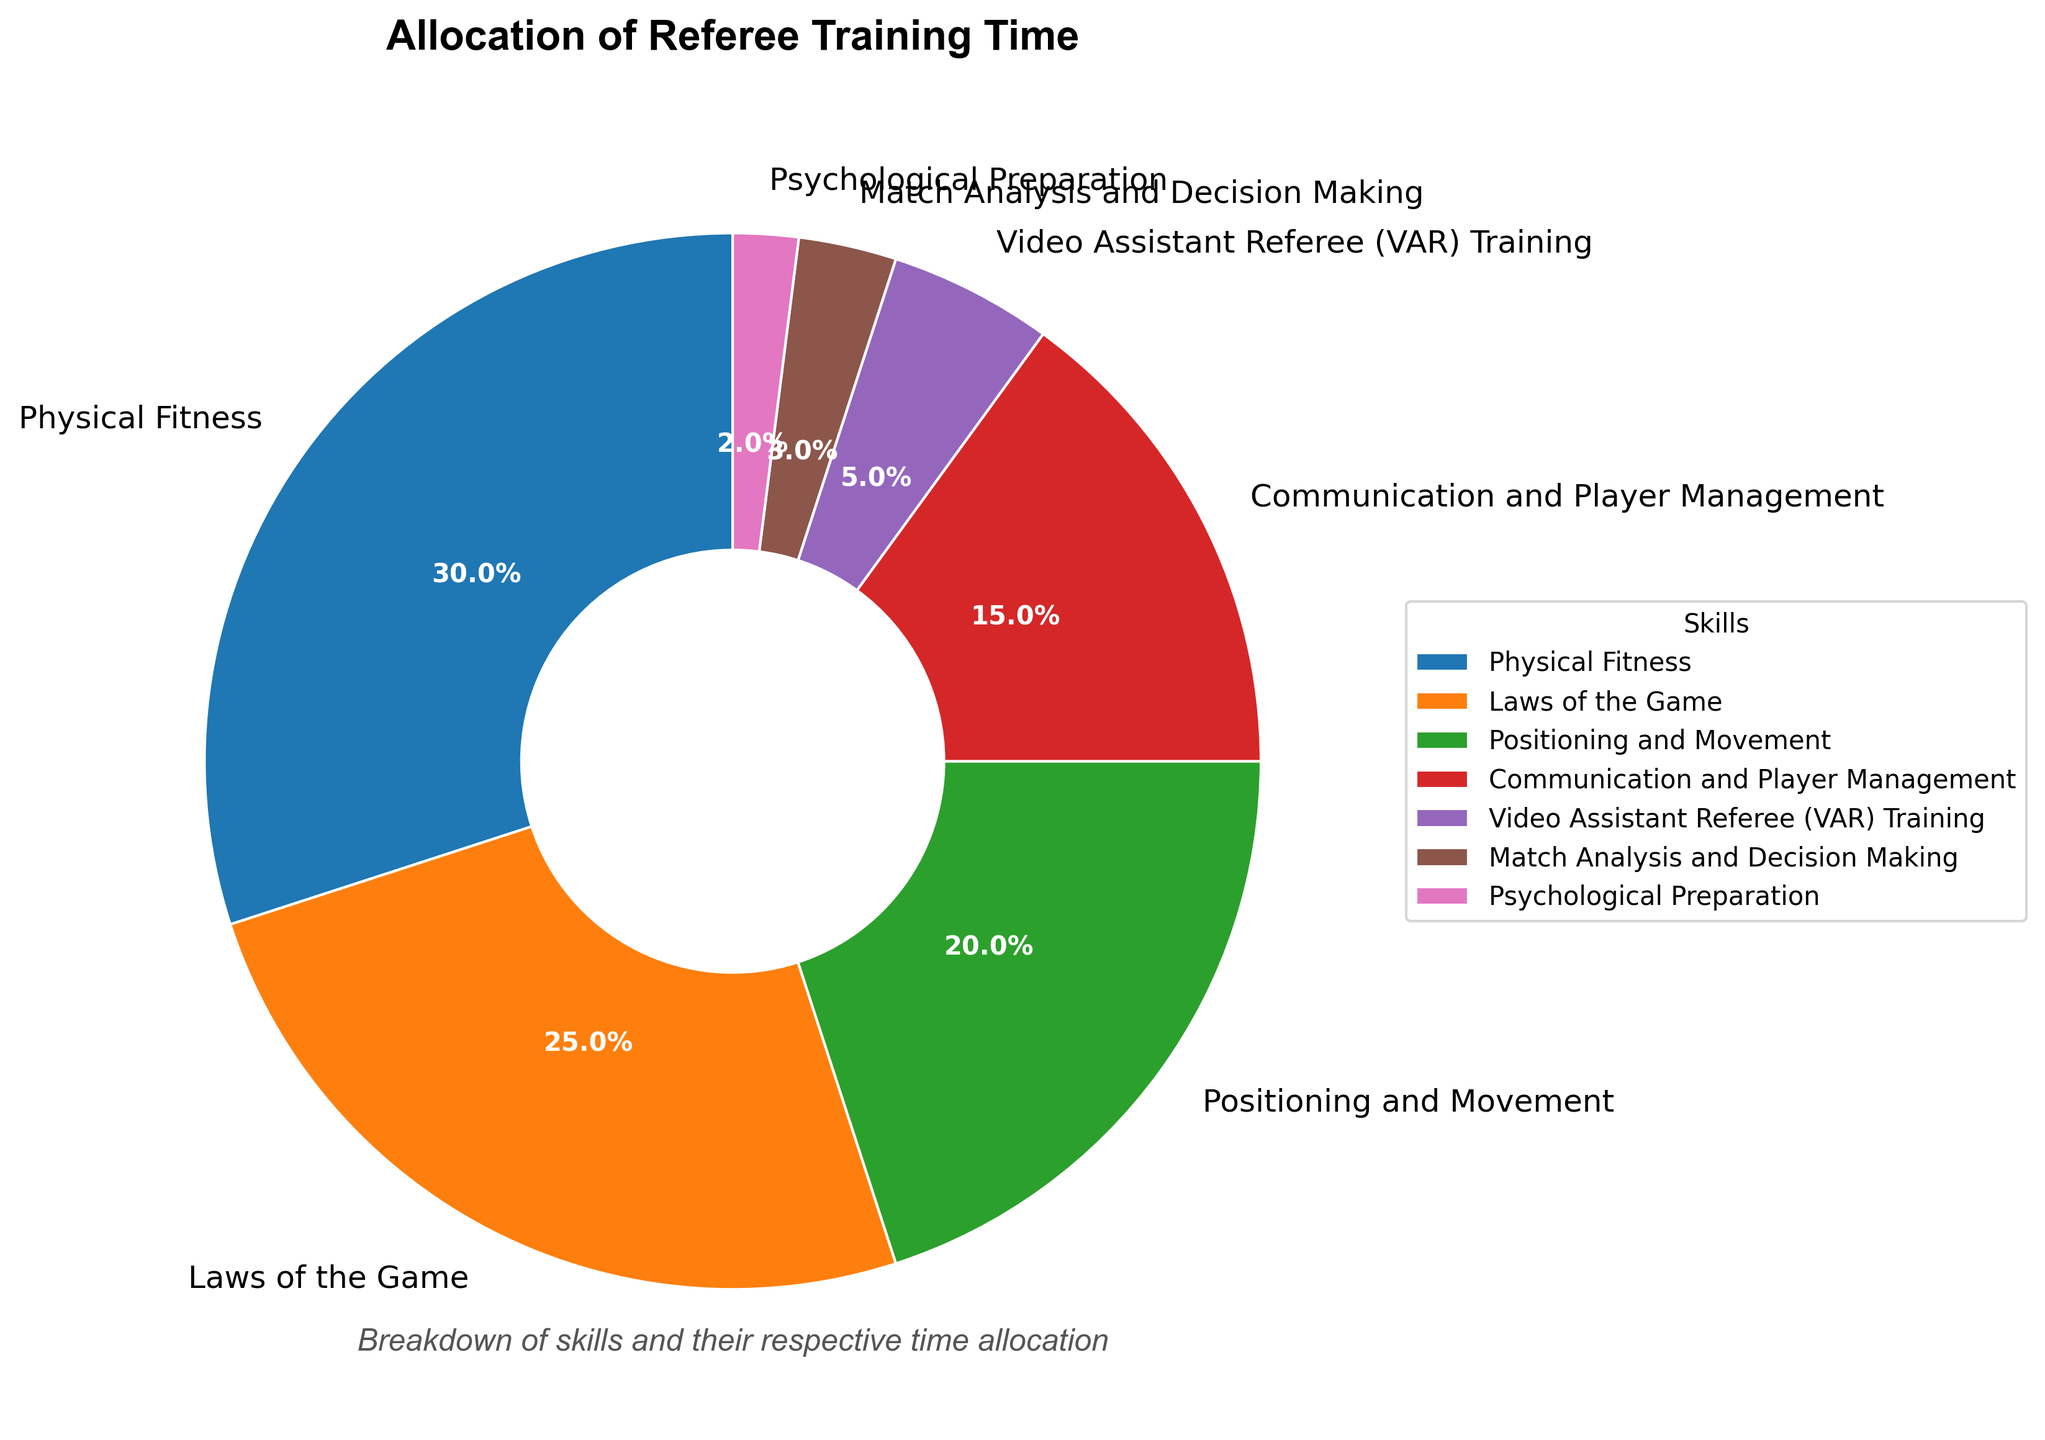how is the training time allocated among different referee skills? The pie chart allocates training time as follows: Physical Fitness (30%), Laws of the Game (25%), Positioning and Movement (20%), Communication and Player Management (15%), Video Assistant Referee (VAR) Training (5%), Match Analysis and Decision Making (3%), and Psychological Preparation (2%).
Answer: Physical Fitness (30%), Laws of the Game (25%), Positioning and Movement (20%), Communication and Player Management (15%), Video Assistant Referee (VAR) Training (5%), Match Analysis and Decision Making (3%), Psychological Preparation (2%) Which skill receives the highest percentage of training time? By examining the pie chart, the skill with the largest wedge labeled as 30% corresponds to Physical Fitness.
Answer: Physical Fitness Which two skills combined account for half of the total training time? Combining the percentages of the two largest wedges, Physical Fitness (30%) and Laws of the Game (25%) results in 30% + 25% = 55%.
Answer: Physical Fitness and Laws of the Game Which skill has the lowest percentage share? The smallest wedge, labeled as 2%, corresponds to Psychological Preparation.
Answer: Psychological Preparation What is the difference in training time percentage between Positioning and Movement and Communication and Player Management? Positioning and Movement is 20% and Communication and Player Management is 15%. The difference is 20% - 15% = 5%.
Answer: 5% Are VAR Training and Match Analysis' combined percentage greater than Communication and Player Management alone? VAR Training (5%) + Match Analysis and Decision Making (3%) equals 8%, while Communication and Player Management alone is 15%. 8% is less than 15%.
Answer: No If the combined percentage for Physical Fitness, Laws of the Game, and Communication and Player Management was plotted, what would it be? Adding the percentages for Physical Fitness (30%) + Laws of the Game (25%) + Communication and Player Management (15%) results in 30% + 25% + 15% = 70%.
Answer: 70% How do the percentages for Positioning and Movement, Communication and Player Management, and Match Analysis and Decision Making compare to each other? Positioning and Movement is 20%, Communication and Player Management is 15%, and Match Analysis is 3%. The comparison is: Positioning and Movement > Communication and Player Management > Match Analysis and Decision Making.
Answer: 20% > 15% > 3% Is the time allocated to Psychological Preparation more or less than that for Match Analysis and Decision Making? Psychological Preparation is 2% and Match Analysis and Decision Making is 3%. 2% is less than 3%.
Answer: Less 